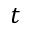<formula> <loc_0><loc_0><loc_500><loc_500>t</formula> 